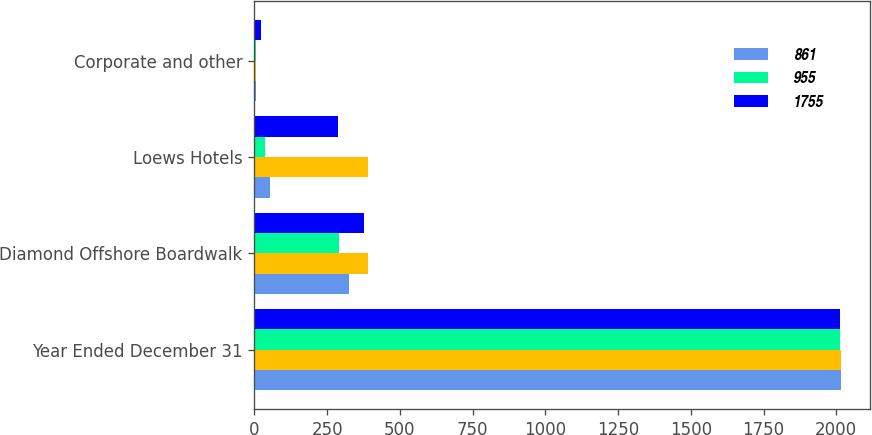Convert chart. <chart><loc_0><loc_0><loc_500><loc_500><stacked_bar_chart><ecel><fcel>Year Ended December 31<fcel>Diamond Offshore Boardwalk<fcel>Loews Hotels<fcel>Corporate and other<nl><fcel>861<fcel>2015<fcel>327<fcel>54<fcel>6<nl><fcel>nan<fcel>2015<fcel>390<fcel>389<fcel>4<nl><fcel>955<fcel>2014<fcel>292<fcel>37<fcel>6<nl><fcel>1755<fcel>2014<fcel>378<fcel>289<fcel>24<nl></chart> 